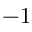Convert formula to latex. <formula><loc_0><loc_0><loc_500><loc_500>- 1</formula> 